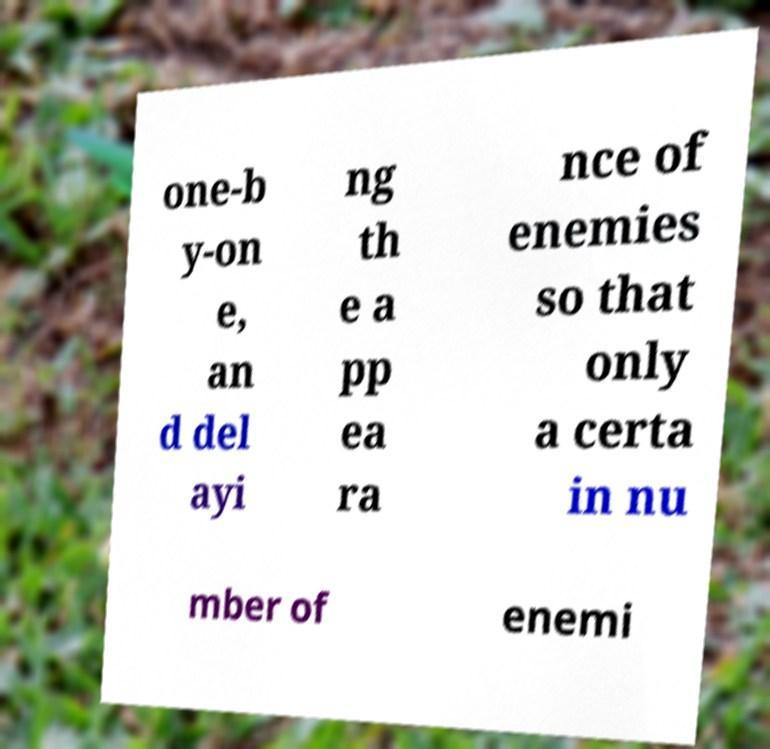Could you assist in decoding the text presented in this image and type it out clearly? one-b y-on e, an d del ayi ng th e a pp ea ra nce of enemies so that only a certa in nu mber of enemi 